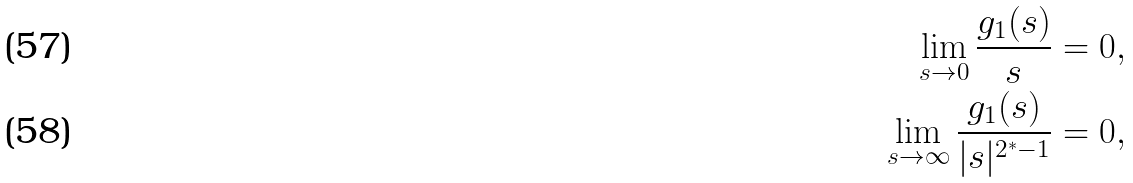Convert formula to latex. <formula><loc_0><loc_0><loc_500><loc_500>\lim _ { s \to 0 } \frac { g _ { 1 } ( s ) } { s } & = 0 , \\ \lim _ { s \to \infty } \frac { g _ { 1 } ( s ) } { | s | ^ { 2 ^ { * } - 1 } } & = 0 ,</formula> 